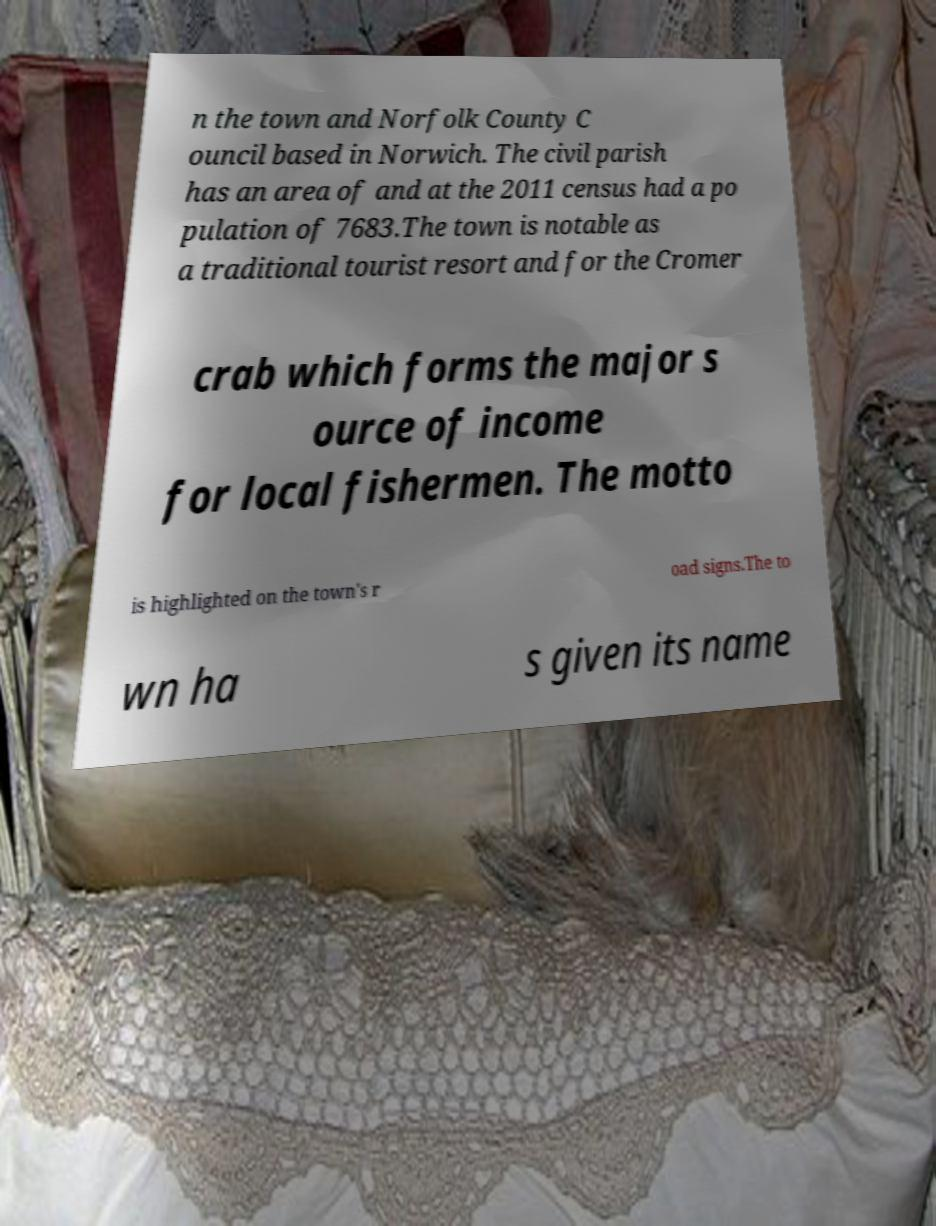Could you extract and type out the text from this image? n the town and Norfolk County C ouncil based in Norwich. The civil parish has an area of and at the 2011 census had a po pulation of 7683.The town is notable as a traditional tourist resort and for the Cromer crab which forms the major s ource of income for local fishermen. The motto is highlighted on the town's r oad signs.The to wn ha s given its name 